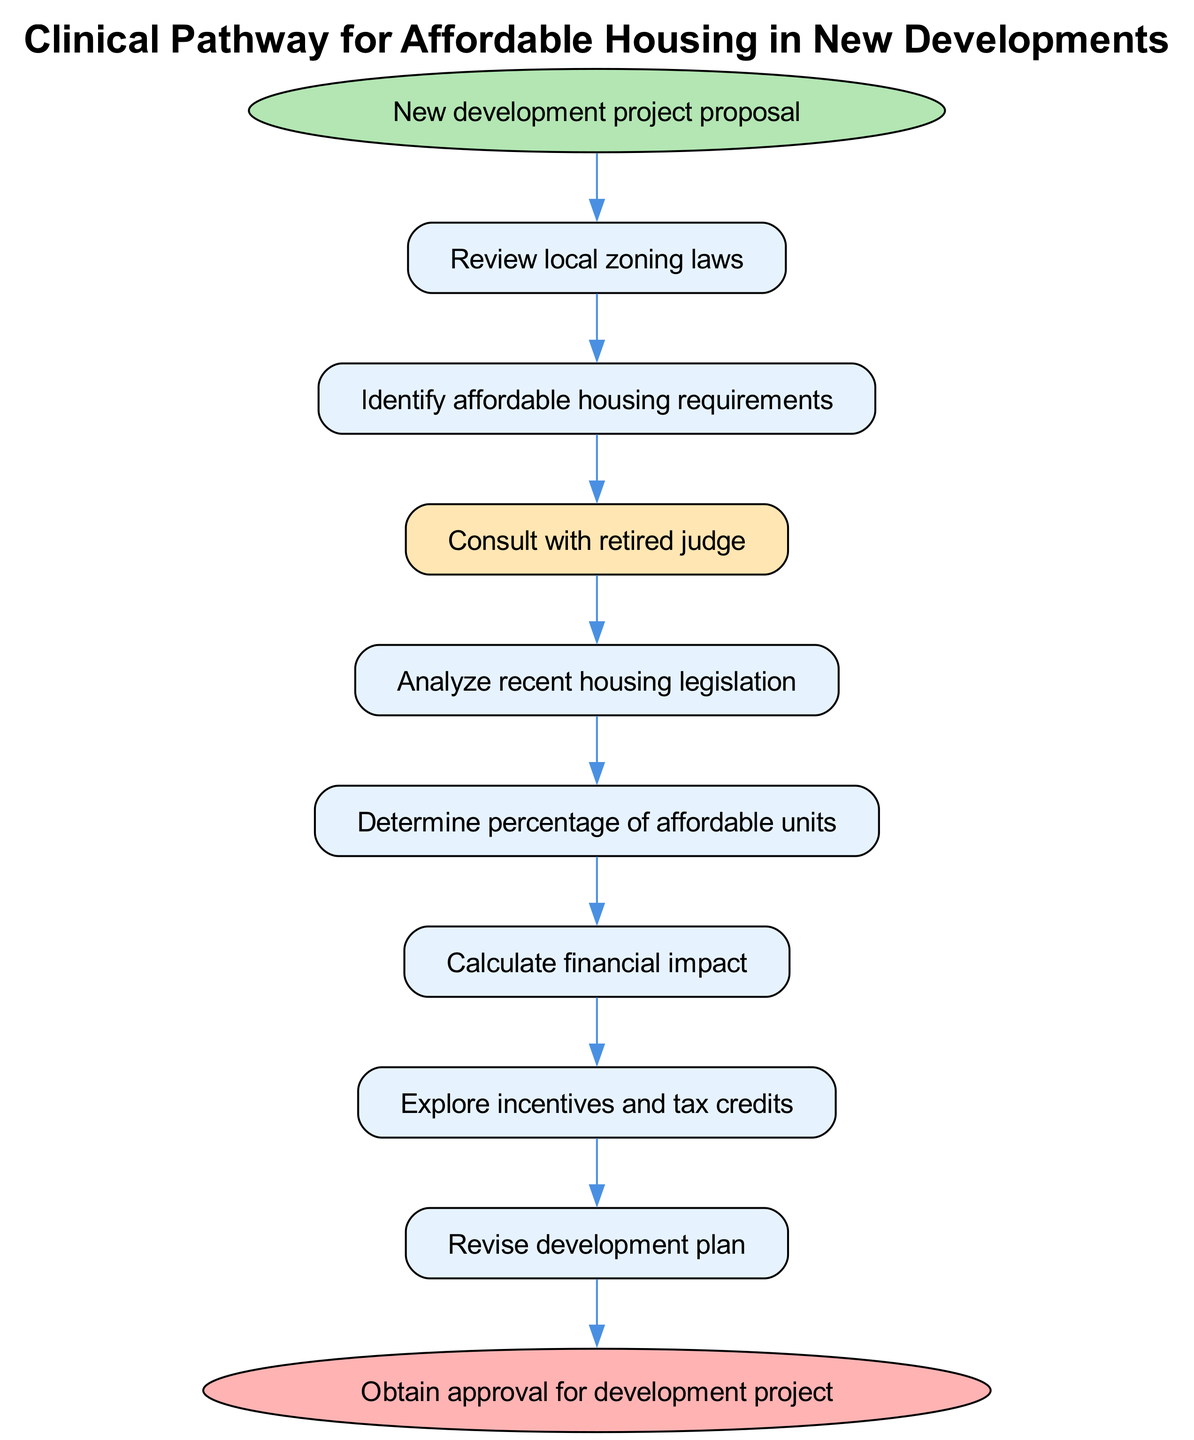What is the starting point of the clinical pathway? The starting point is labeled as "New development project proposal" in the diagram, indicating the initiation of the process for addressing affordable housing requirements.
Answer: New development project proposal How many steps are there in the pathway? The diagram outlines eight distinct steps leading to the end point, shown through nodes connected in a sequential manner.
Answer: 8 What is the last step before obtaining the project approval? The last step before reaching the end of the pathway is "Submit proposal to local housing authority," which directly precedes the final approval node.
Answer: Submit proposal to local housing authority Which step emphasizes consultation with the retired judge? The step "Consult with retired judge" is uniquely highlighted in the diagram, drawing attention to its significance in the pathway.
Answer: Consult with retired judge What follows the "Explore incentives and tax credits" step? The next step following "Explore incentives and tax credits" is "Revise development plan," indicating a necessary adjustment after exploring financial options.
Answer: Revise development plan How do local zoning laws relate to identifying affordable housing requirements? The pathway starts with "Review local zoning laws," which feeds directly into the next step of "Identify affordable housing requirements," showing this connection.
Answer: Identify affordable housing requirements What color highlights the consultation step in the diagram? The consultation step is highlighted in a yellowish color (#FFE6B3), distinguishing it from the other steps in the pathway.
Answer: Yellowish What is the immediate step preceding "Determine percentage of affordable units"? The step immediately preceding "Determine percentage of affordable units" is "Analyze recent housing legislation," showing a direct flow from one process to the next.
Answer: Analyze recent housing legislation What type of impact is calculated according to the pathway? The pathway includes a step to "Calculate financial impact," indicating a focus on the economic aspects of affordable housing requirements.
Answer: Financial impact 